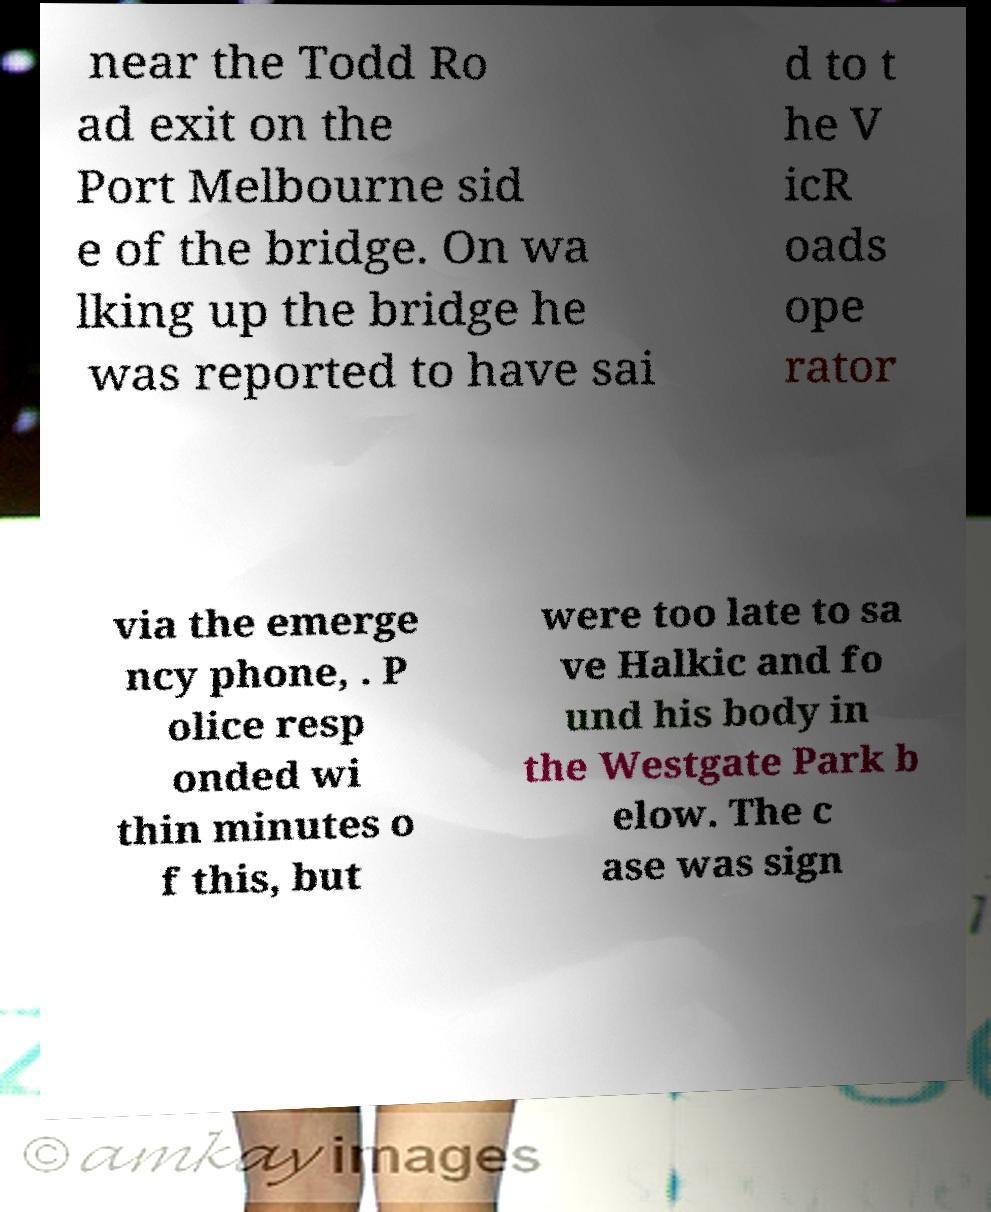For documentation purposes, I need the text within this image transcribed. Could you provide that? near the Todd Ro ad exit on the Port Melbourne sid e of the bridge. On wa lking up the bridge he was reported to have sai d to t he V icR oads ope rator via the emerge ncy phone, . P olice resp onded wi thin minutes o f this, but were too late to sa ve Halkic and fo und his body in the Westgate Park b elow. The c ase was sign 